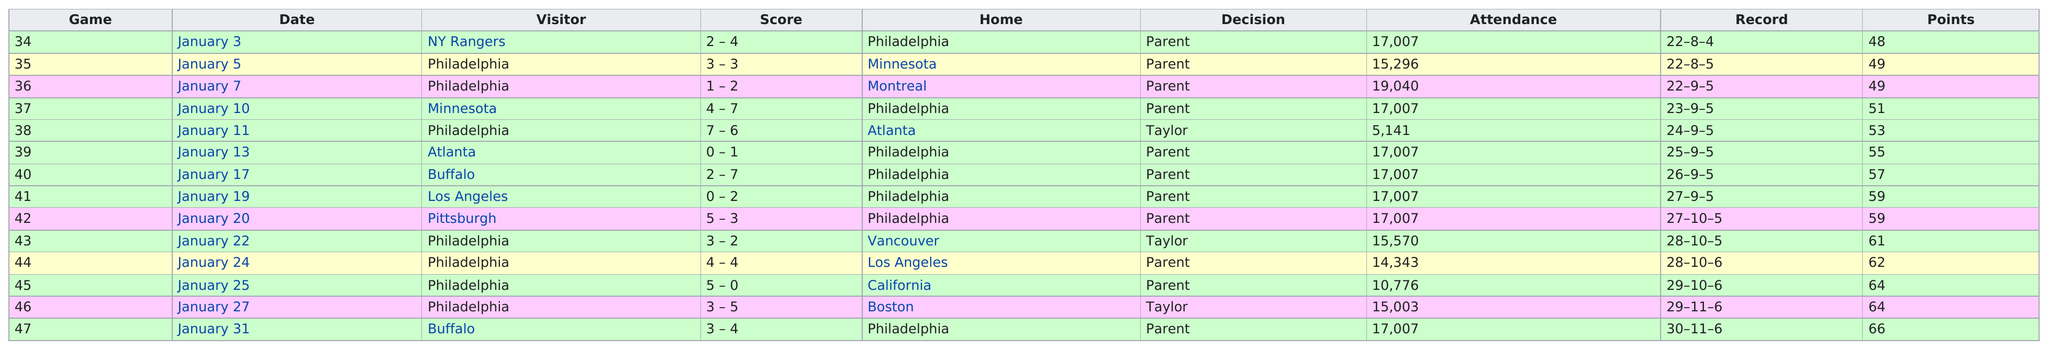Draw attention to some important aspects in this diagram. During the 1973-74 season, the Philadelphia Flyers scored a total of 273 goals. The number of attendance for the Philadelphia Flyers in the 1973-74 season was 17,007. The Flyers defeated the Atlanta Flames in a four-game series, sweeping them to secure victory. Keith Allen was the general manager of the team, not Joe Watson. In the 1973-74 regular season, the Philadelphia Flyers played a total of 78 games. 